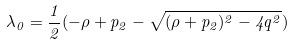<formula> <loc_0><loc_0><loc_500><loc_500>\lambda _ { 0 } = \frac { 1 } { 2 } ( - \rho + p _ { 2 } - \sqrt { ( \rho + p _ { 2 } ) ^ { 2 } - 4 q ^ { 2 } } )</formula> 